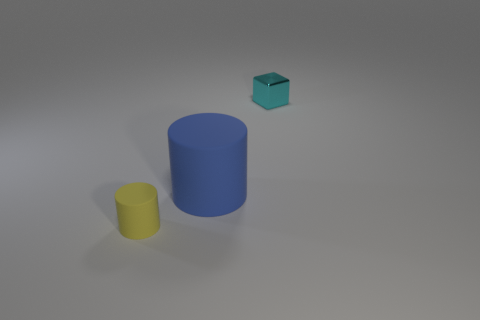Add 1 blue matte things. How many objects exist? 4 Subtract all cylinders. How many objects are left? 1 Subtract all cyan matte objects. Subtract all small cyan cubes. How many objects are left? 2 Add 1 blue matte objects. How many blue matte objects are left? 2 Add 2 large red matte blocks. How many large red matte blocks exist? 2 Subtract 0 purple cylinders. How many objects are left? 3 